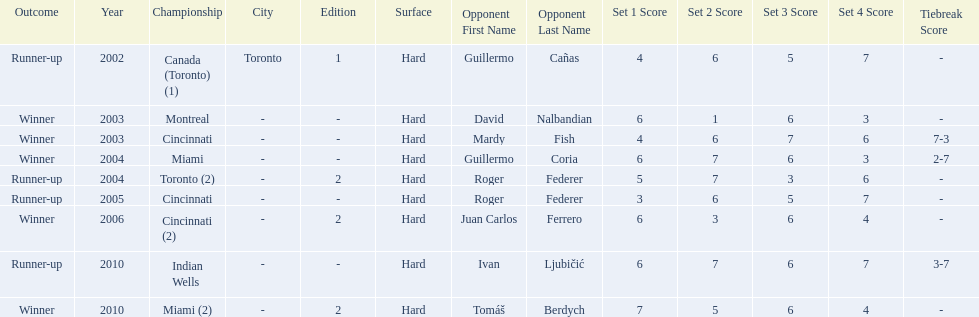How many championships occurred in toronto or montreal? 3. 